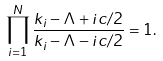<formula> <loc_0><loc_0><loc_500><loc_500>\prod _ { i = 1 } ^ { N } \frac { k _ { i } - \Lambda + i c / 2 } { k _ { i } - \Lambda - i c / 2 } = 1 .</formula> 